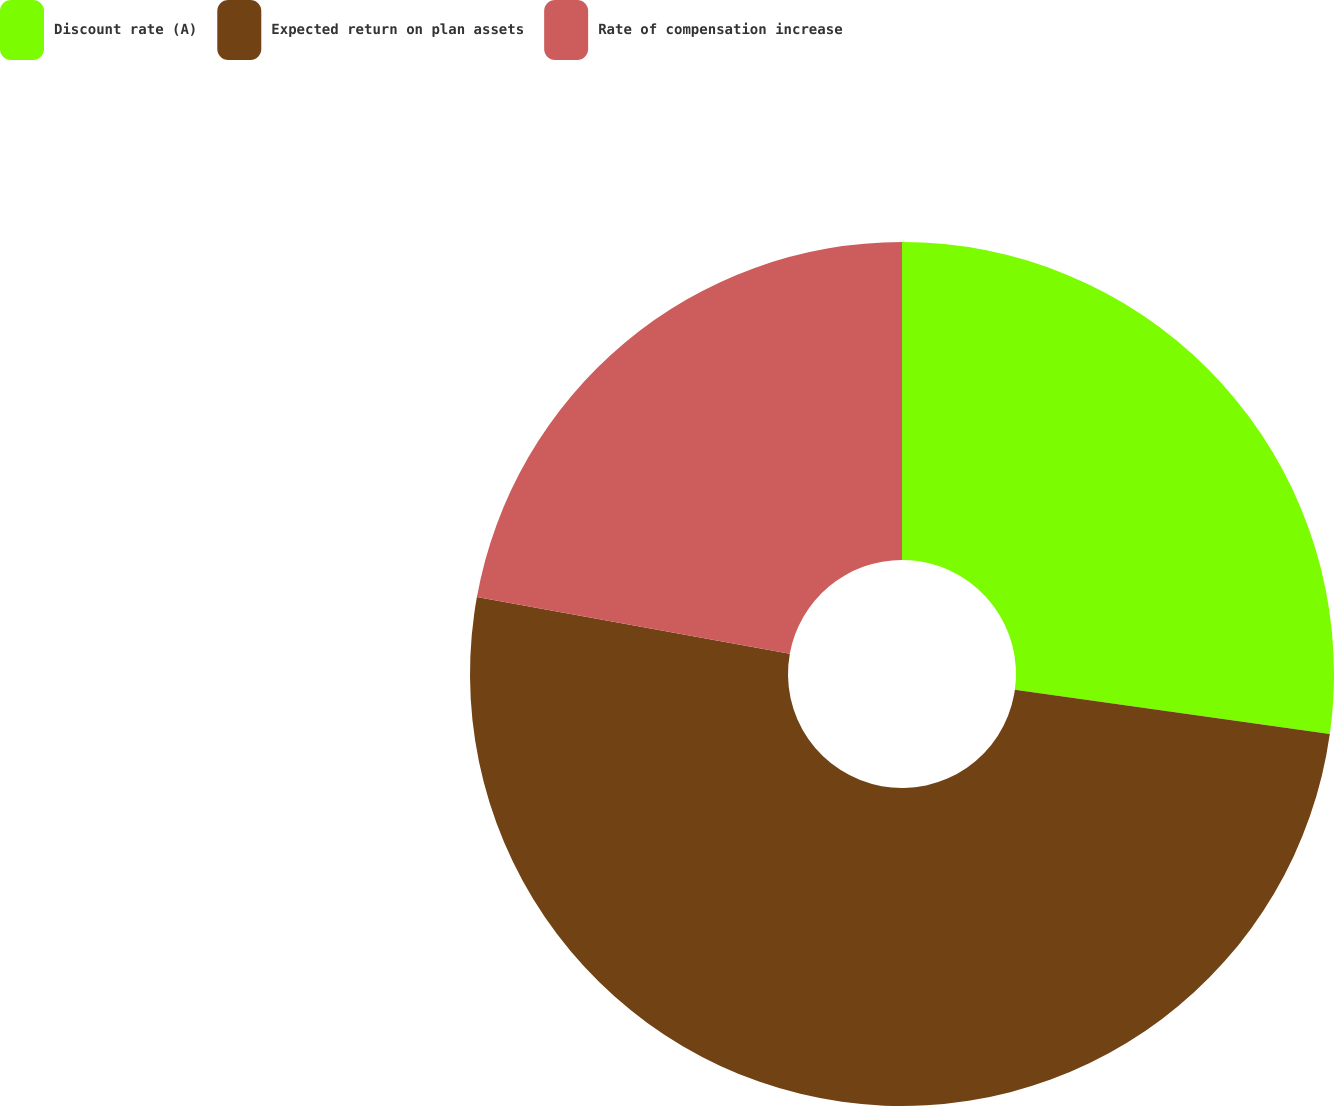Convert chart. <chart><loc_0><loc_0><loc_500><loc_500><pie_chart><fcel>Discount rate (A)<fcel>Expected return on plan assets<fcel>Rate of compensation increase<nl><fcel>27.22%<fcel>50.63%<fcel>22.15%<nl></chart> 